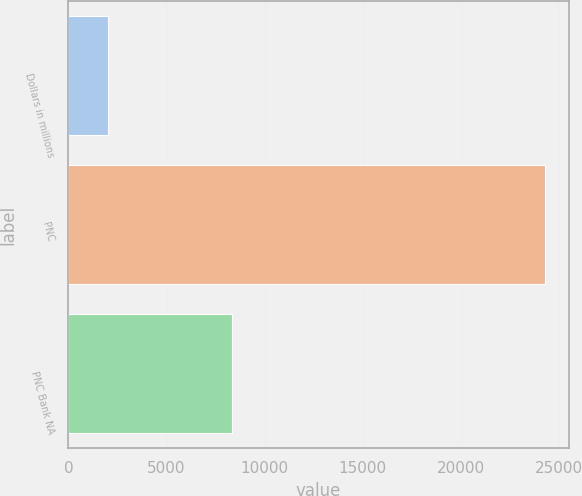Convert chart. <chart><loc_0><loc_0><loc_500><loc_500><bar_chart><fcel>Dollars in millions<fcel>PNC<fcel>PNC Bank NA<nl><fcel>2008<fcel>24287<fcel>8338<nl></chart> 